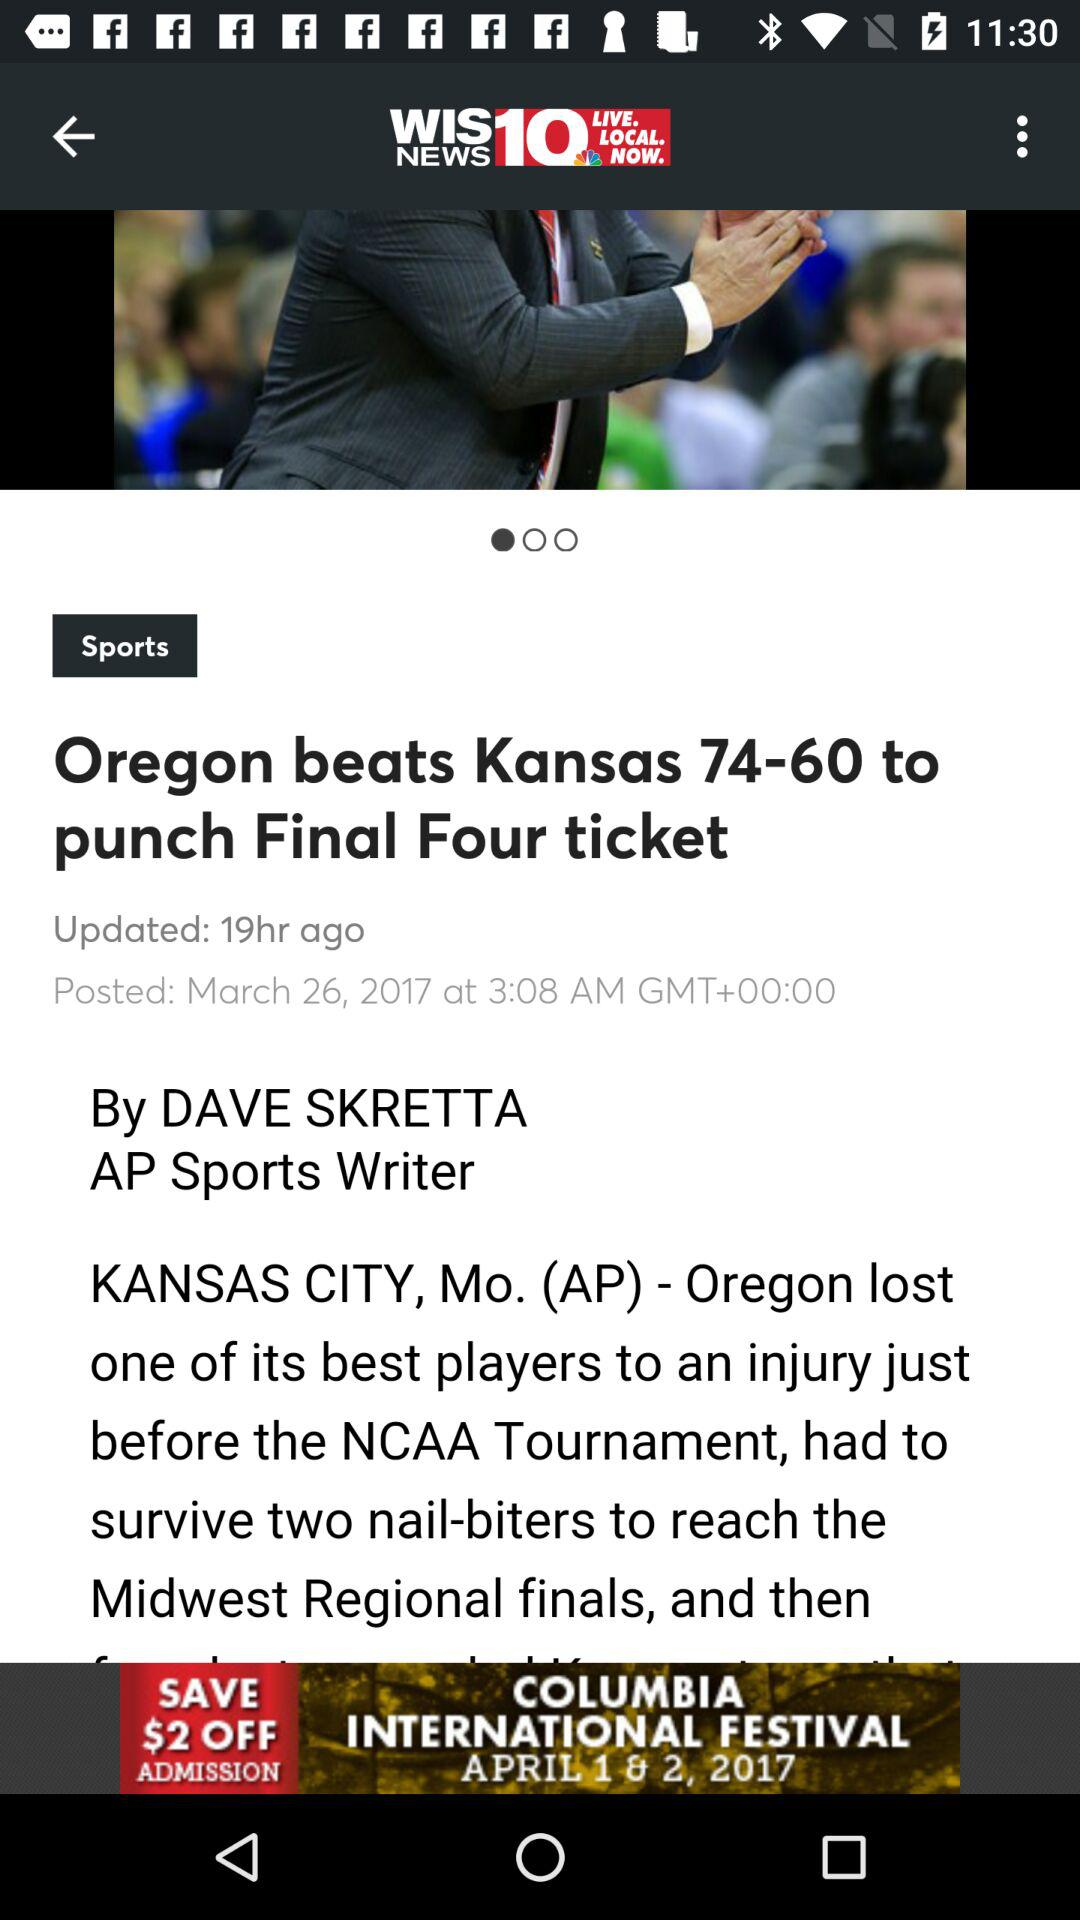When was the news posted? The news was posted on March 26, 2017 at 3:08 AM GMT+00:00. 